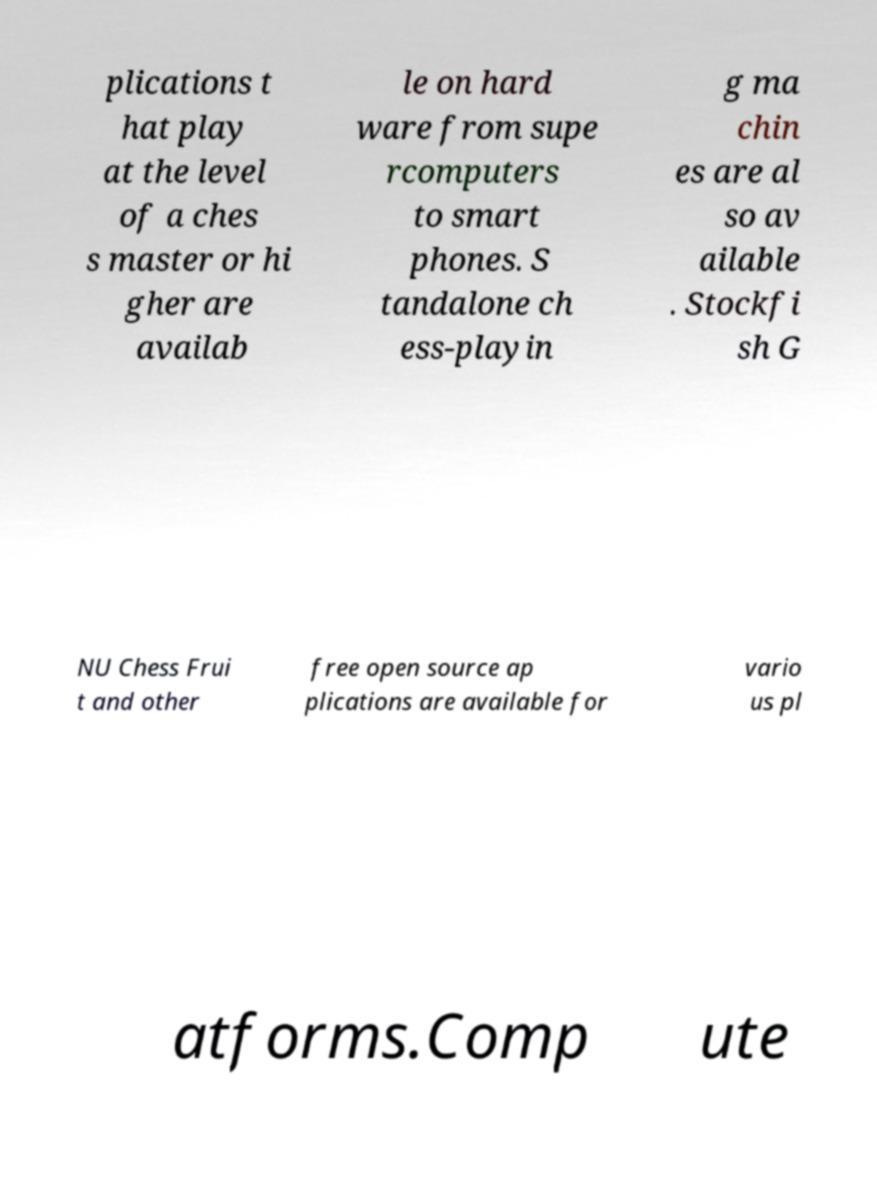Can you read and provide the text displayed in the image?This photo seems to have some interesting text. Can you extract and type it out for me? plications t hat play at the level of a ches s master or hi gher are availab le on hard ware from supe rcomputers to smart phones. S tandalone ch ess-playin g ma chin es are al so av ailable . Stockfi sh G NU Chess Frui t and other free open source ap plications are available for vario us pl atforms.Comp ute 